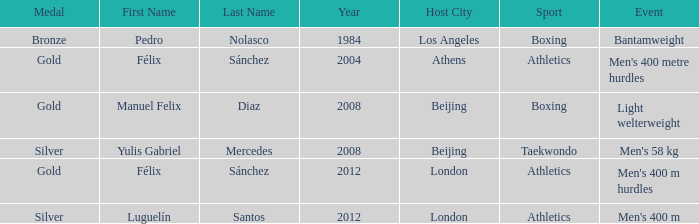In which sport was there an occurrence of men's 400 m hurdles? Athletics. 